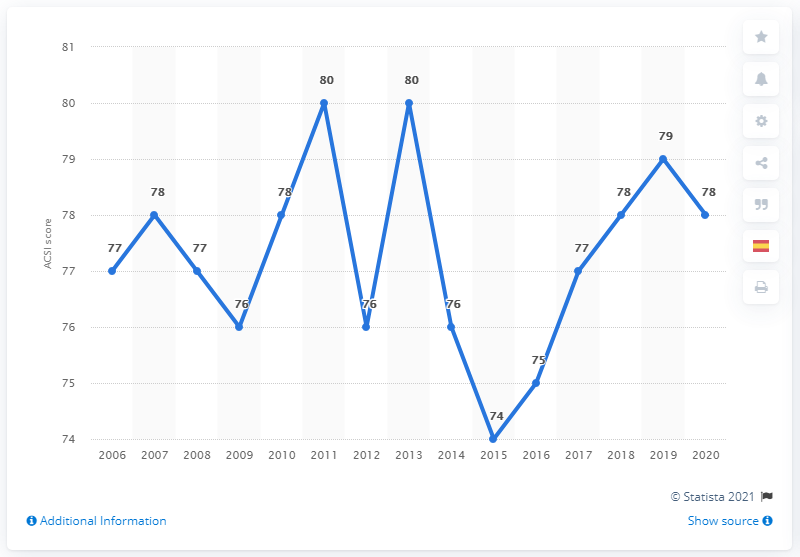Point out several critical features in this image. In 2020, Starbucks received a customer satisfaction index (ACSI) score of 78, which indicates that a large majority of customers were satisfied with their experiences at Starbucks. 